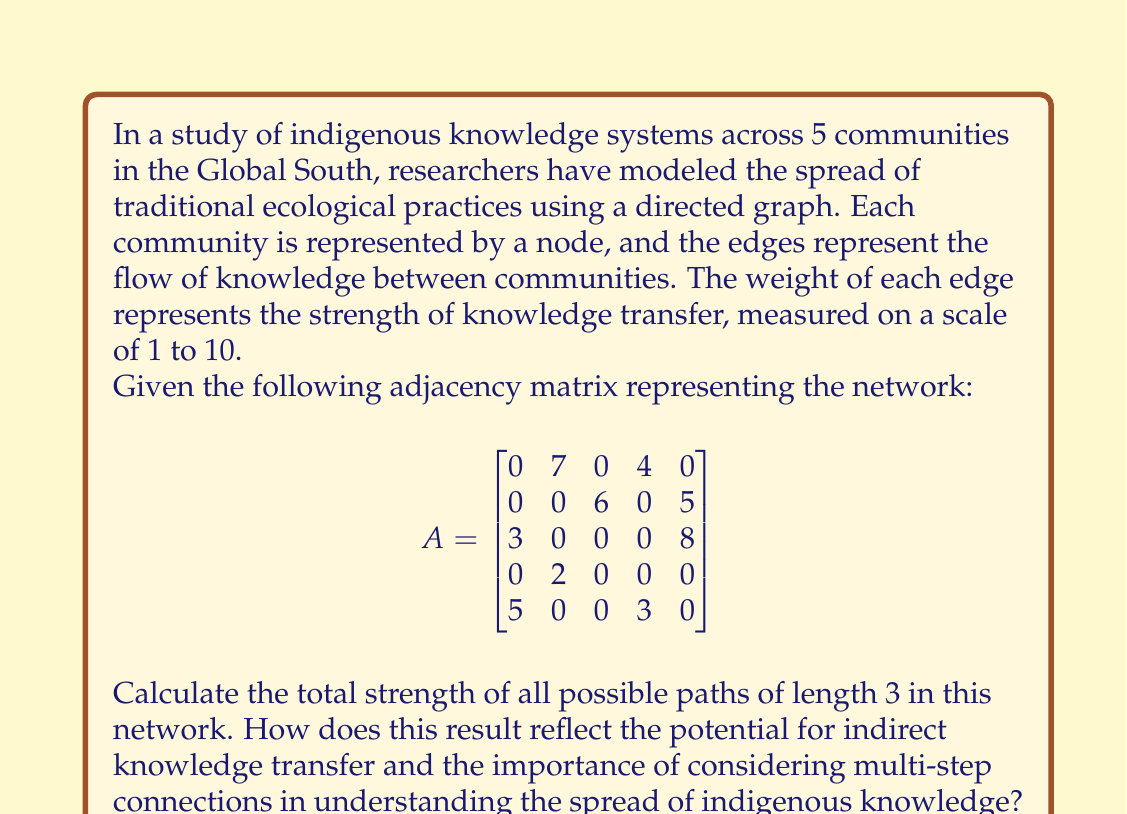Can you solve this math problem? To solve this problem, we need to use matrix multiplication and graph theory concepts. The process involves the following steps:

1) In a directed graph, the number of paths of length k between two nodes is given by the corresponding entry in the k-th power of the adjacency matrix.

2) Therefore, to find all paths of length 3, we need to calculate $A^3$.

3) Let's perform the matrix multiplication:

   $$A^2 = \begin{bmatrix}
   0 & 14 & 42 & 0 & 35 \\
   15 & 0 & 0 & 18 & 40 \\
   25 & 35 & 0 & 24 & 0 \\
   0 & 0 & 12 & 0 & 10 \\
   0 & 23 & 0 & 12 & 15
   \end{bmatrix}$$

   $$A^3 = \begin{bmatrix}
   105 & 35 & 84 & 126 & 280 \\
   125 & 175 & 0 & 120 & 75 \\
   75 & 161 & 210 & 72 & 200 \\
   30 & 0 & 0 & 36 & 80 \\
   0 & 70 & 252 & 0 & 175
   \end{bmatrix}$$

4) The total strength of all possible paths of length 3 is the sum of all entries in $A^3$.

5) Sum of all entries in $A^3$ = 2386

This result reflects the potential for indirect knowledge transfer in several ways:

a) The high total (2386) indicates significant potential for knowledge to spread indirectly through the network.

b) Some entries in $A^3$ are much larger than any in the original matrix A, showing how indirect connections can be stronger than direct ones.

c) There are non-zero entries in $A^3$ where A had zeros, revealing new connections that emerge when considering multi-step paths.

This analysis underscores the importance of looking beyond immediate, direct connections when studying the spread of indigenous knowledge. It reveals how communities that may not have direct links can still strongly influence each other through intermediaries, creating a rich, interconnected web of knowledge transfer that may not be apparent from studying only direct relationships.
Answer: The total strength of all possible paths of length 3 in this network is 2386. 